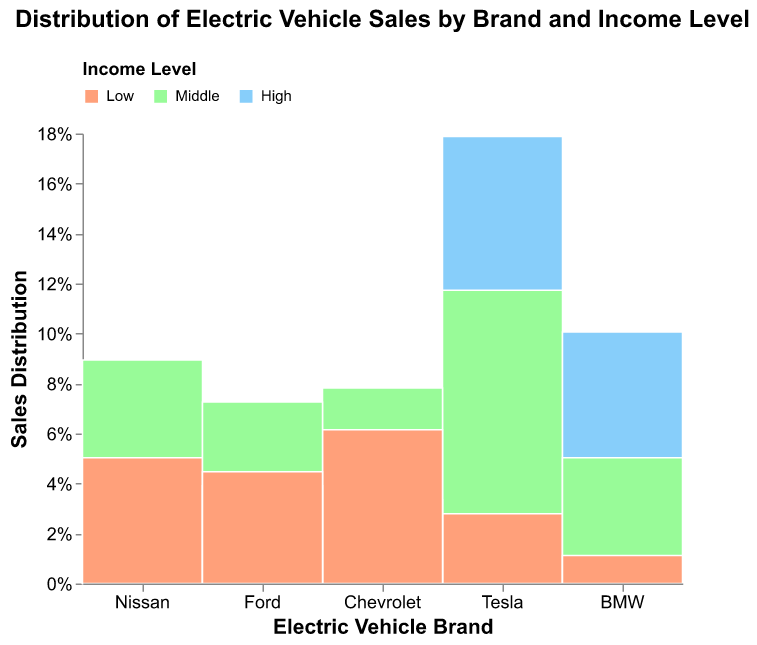How many brands have their highest sales to middle-income consumers? The figure shows the sales distribution of different brands by income levels, represented on the y-axis. We need to identify which brands have the largest portion of their bar in the middle income segment (green). Looking at Tesla, Nissan, Chevrolet, BMW, and Ford, only Nissan, Chevrolet, and Ford have their largest segments in the middle income section.
Answer: 3 Which brand has the highest percentage of sales to high-income customers? To find the brand with the highest percentage of sales to high-income customers, look for the tallest blue segment in the mosaic plot. We see that Tesla has the tallest blue segment, indicating the highest percentage.
Answer: Tesla What is the total percentage of sales contributed by low-income consumers for Chevrolet? We need to find the height of the orange section for Chevrolet in proportion to the total height of Chevrolet's bar. The orange section representing low-income level sales constitutes around 30% of Chevrolet's total sales.
Answer: 30% Compare the percentage of sales to middle-income consumers between Tesla and Ford. Which is higher? Locate the green segments for both Tesla and Ford. Tesla's green segment appears taller compared to Ford's, indicating that Tesla has a higher percentage of sales to middle-income consumers.
Answer: Tesla What percentage of BMW's sales are to low-income consumers? Find the size of the orange segment for BMW and compare it to BMW's total sales height. The plot shows a small orange segment for BMW, indicating that about 10% of BMW's sales are to low-income consumers.
Answer: 10% Which brand has the smallest percentage of sales to low-income customers? Observe the smallest orange segment among all brands. BMW has the smallest orange segment, implying the lowest percentage of sales to low-income customers.
Answer: BMW How does Ford's distribution of sales among income levels compare to Nissan? Compare the relative sizes of the colored segments for Ford and Nissan. Ford has approximately equal distributions among middle-income (green) and low-income (orange) customers, leaning slightly higher in the middle-income segment, whereas Nissan has more middle-income sales, followed by high-income, and then low-income.
Answer: Ford has more evenly distributed sales among middle and low, Nissan leans toward middle-income sales In terms of percentage, which income group contributes the least to Tesla's sales? Examine the segments for Tesla. The smallest segment is the orange one, which represents the low-income group.
Answer: Low-income In the figure, how do sales to high-income customers of Chevrolet compare to those of Ford? Compare the sizes of the blue segments for both Chevrolet and Ford. Chevrolet’s blue segment is smaller than Ford's, indicating that Chevrolet has fewer sales to high-income customers compared to Ford.
Answer: Smaller 